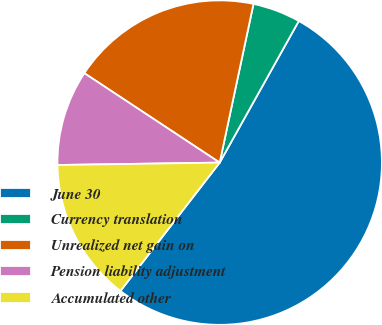Convert chart to OTSL. <chart><loc_0><loc_0><loc_500><loc_500><pie_chart><fcel>June 30<fcel>Currency translation<fcel>Unrealized net gain on<fcel>Pension liability adjustment<fcel>Accumulated other<nl><fcel>52.37%<fcel>4.77%<fcel>19.05%<fcel>9.53%<fcel>14.29%<nl></chart> 